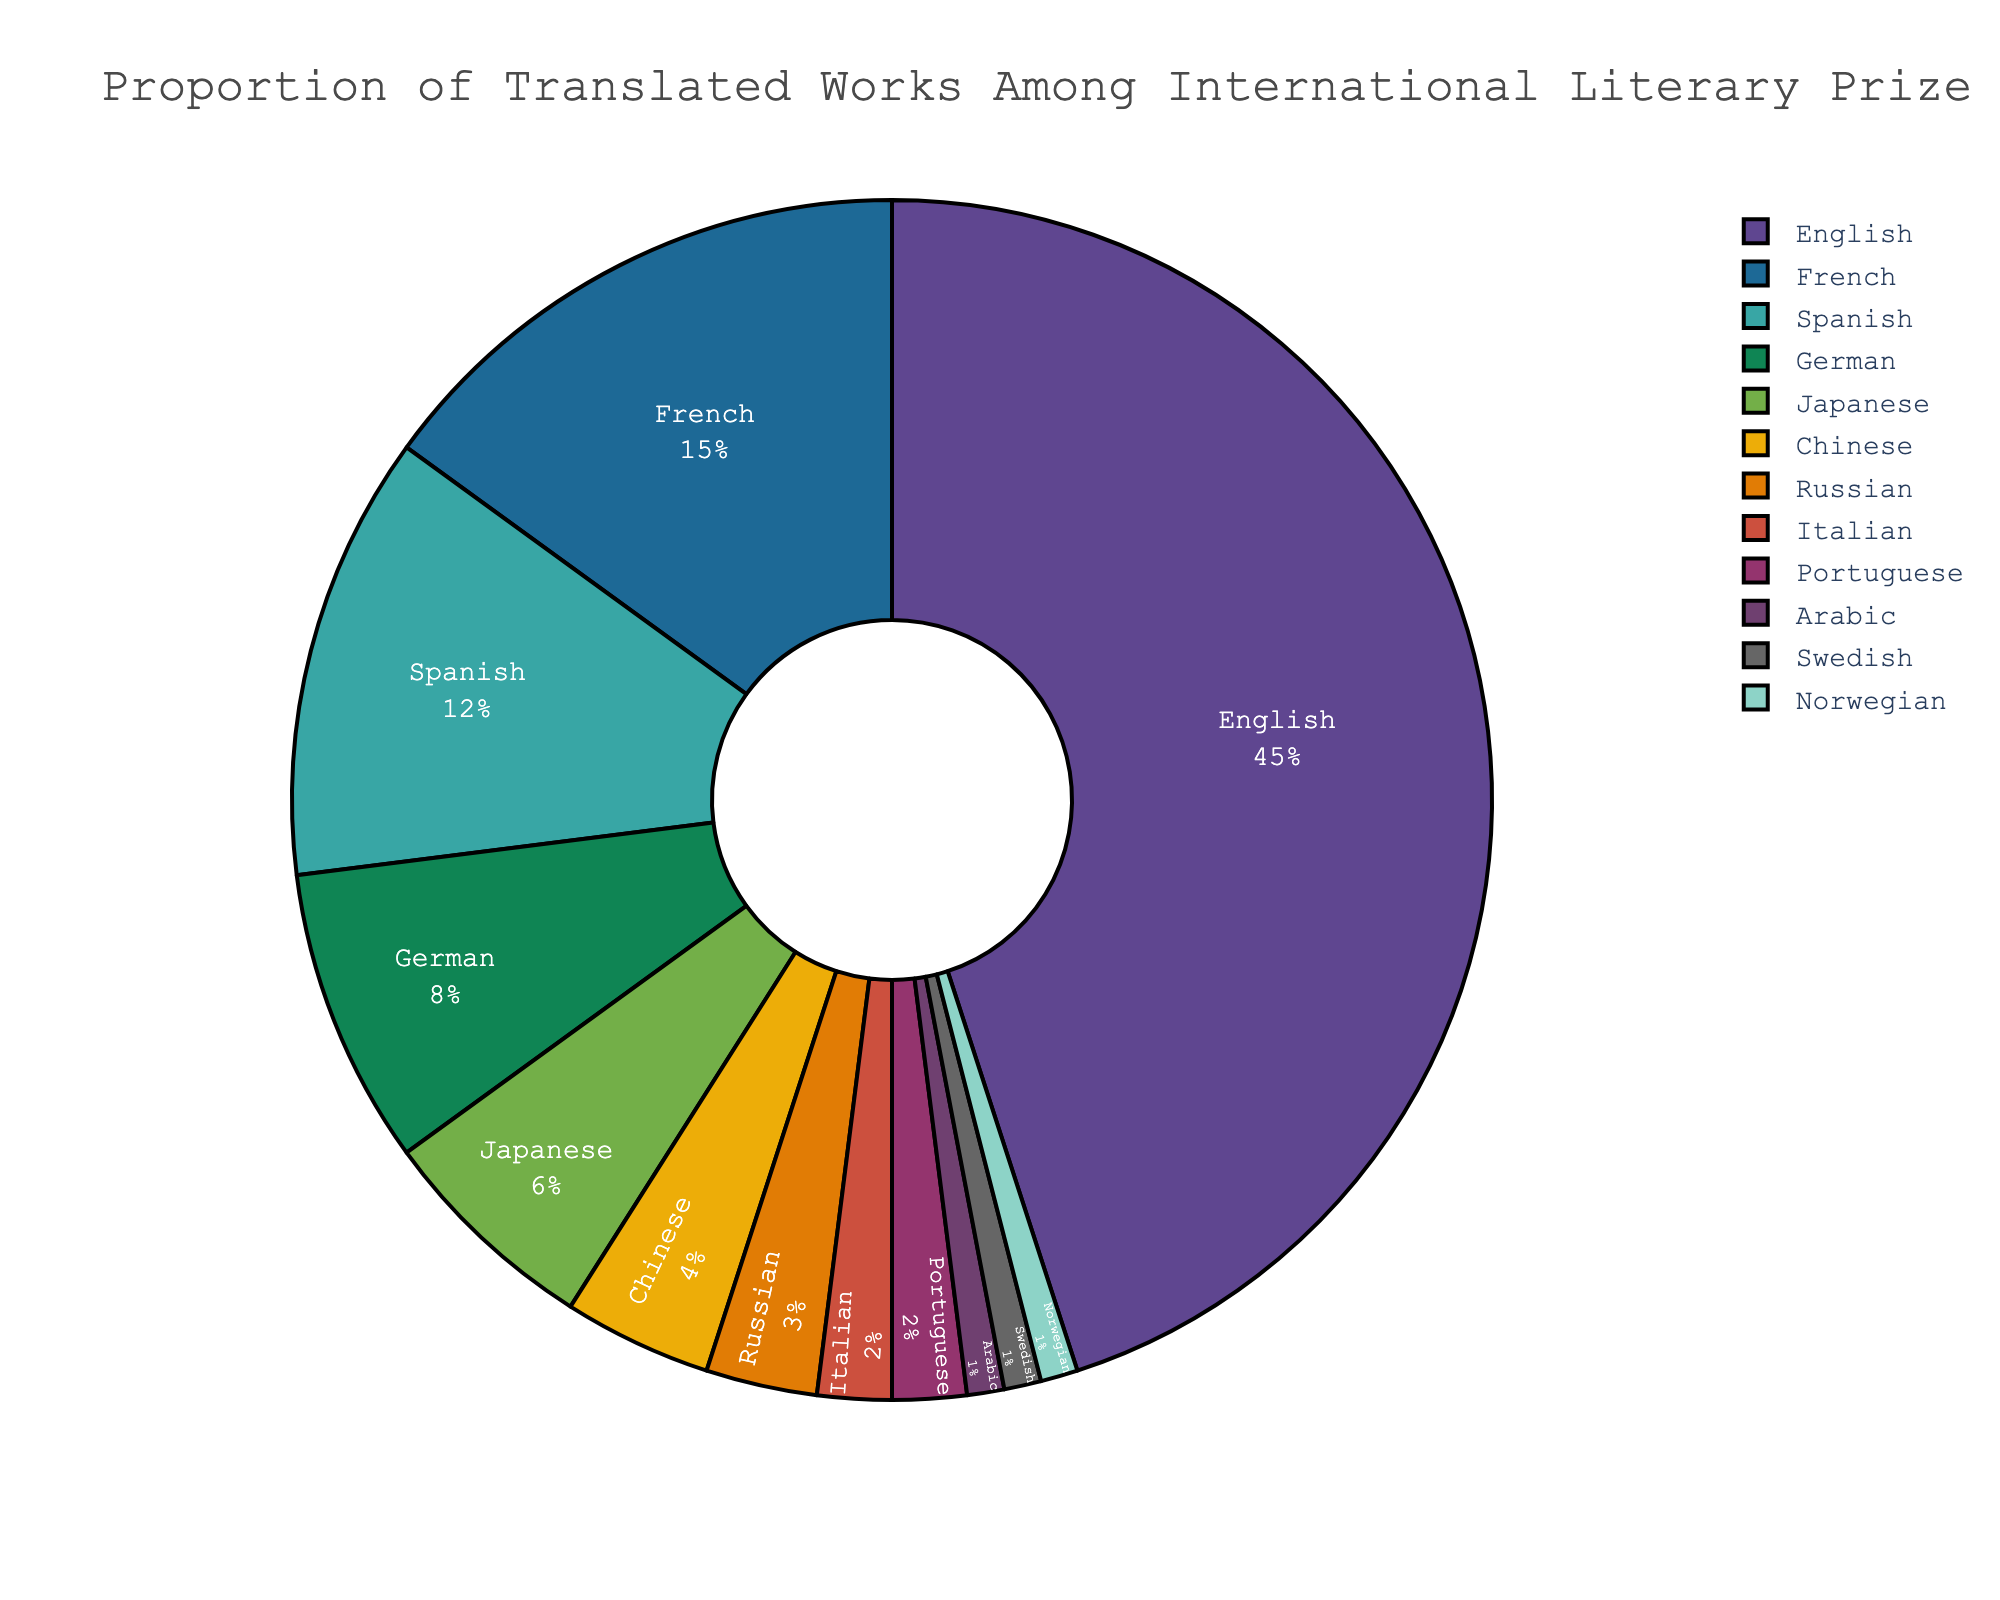What's the largest proportion of translated works among the international literary prize winners? The pie chart shows that English has the largest proportion. From the data, we see that English has a percentage of 45%, which is the highest.
Answer: English, 45% Which two languages together make up the smallest proportion of translated works? From the pie chart, we can see that Arabic, Swedish, and Norwegian each make up 1%, the smallest proportions among all languages. Summing the percentages of any two of these yields 2%, which is the smallest value possible for a pair of languages. Therefore, we can choose either Arabic & Swedish, Arabic & Norwegian, or Swedish & Norwegian.
Answer: Arabic & Swedish (or  Arabic & Norwegian or  Swedish & Norwegian), 1% + 1% = 2% By how much does the proportion of English translated works exceed the proportion of French translated works? According to the pie chart, English has a 45% share and French has a 15% share. The difference between these two proportions is 45% - 15%.
Answer: 30% What proportion of the prize winners' works are translated into Eastern languages (Chinese, Japanese)? From the figure, Chinese has a percentage of 4% and Japanese has 6%. Summing these values, 4% + 6%, gives the combined proportion for Eastern languages.
Answer: 10% What is the difference in proportion between the languages with the third and fifth highest translated works? Spanish has the third highest proportion with 12% and Japanese has the fifth highest proportion with 6%. The difference between these values is 12% - 6%.
Answer: 6% If the total number of prize-winning works is 1000, how many of them are translated into German? From the pie chart, German constitutes 8% of the total. If the total number of prize-winning works is 1000, then the number of works translated into German is 8% of 1000, which is calculated as (8/100) * 1000.
Answer: 80 Which languages together make up more than half of the translated literary prize winners' works and what is their combined proportion? From the figure, English (45%), French (15%), and Spanish (12%) are the top three languages. Adding these together gives 45% + 15% + 12%, which totals 72%. Since 72% is more than half of 100%, these three languages together make up more than half of the combined translated works.
Answer: English, French, and Spanish, 72% How many languages have a proportion of less than 5% of the translated literary prize winners' works? From the figure, Chinese (4%), Russian (3%), Italian (2%), Portuguese (2%), Arabic (1%), Swedish (1%), and Norwegian (1%) all have proportions less than 5%. Counting these, we get a total of 7 languages.
Answer: 7 